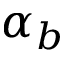Convert formula to latex. <formula><loc_0><loc_0><loc_500><loc_500>\alpha _ { b }</formula> 